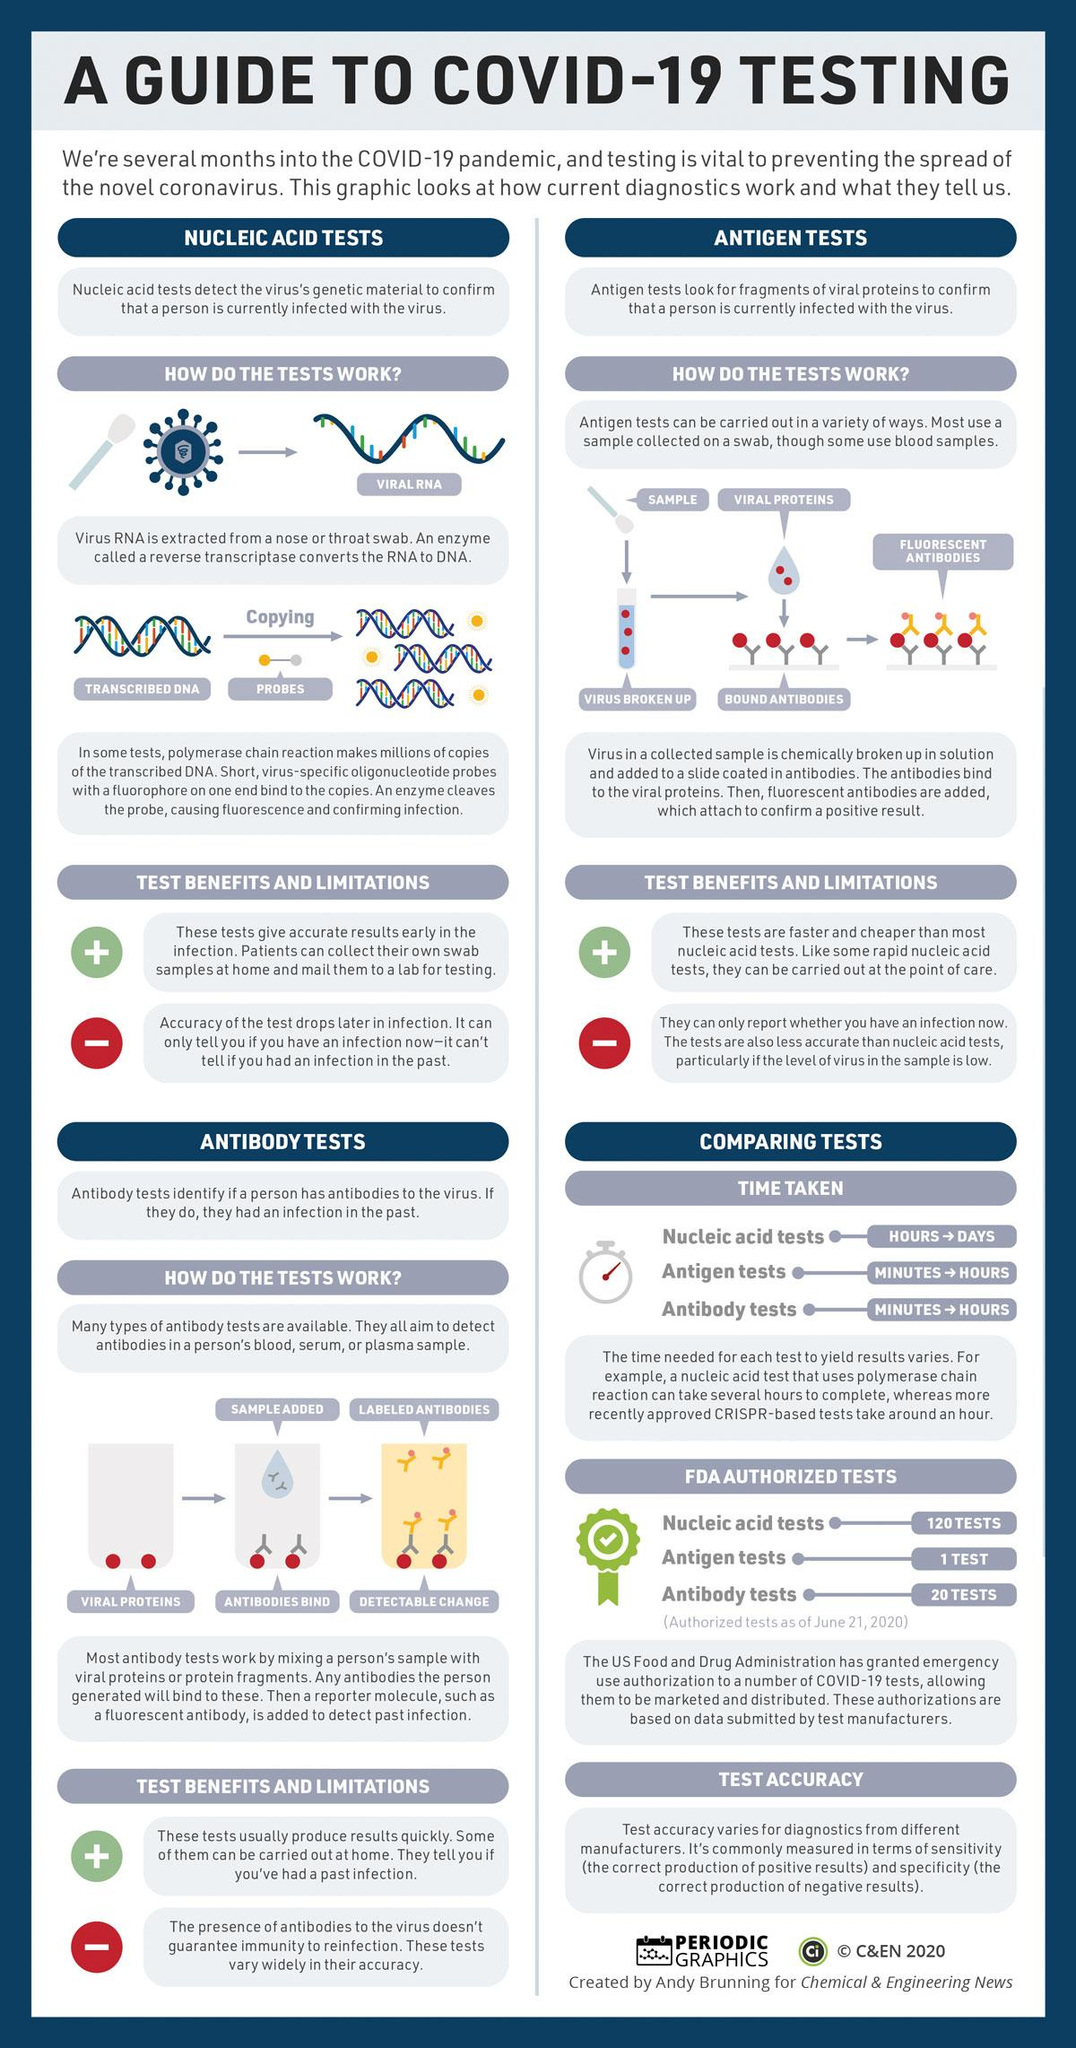Point out several critical features in this image. All parts of the body are susceptible to virus RNA collection, with the most common sites of collection being the nose and throat. It is the enzyme known as reverse transcriptase that converts RNA to DNA. 